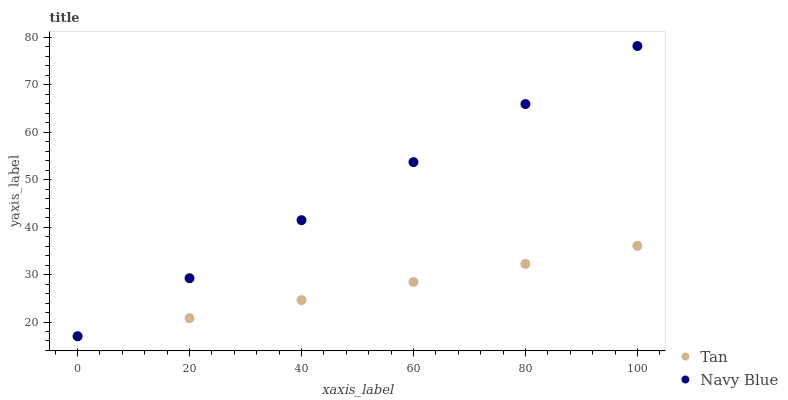Does Tan have the minimum area under the curve?
Answer yes or no. Yes. Does Navy Blue have the maximum area under the curve?
Answer yes or no. Yes. Does Tan have the maximum area under the curve?
Answer yes or no. No. Is Navy Blue the smoothest?
Answer yes or no. Yes. Is Tan the roughest?
Answer yes or no. Yes. Is Tan the smoothest?
Answer yes or no. No. Does Navy Blue have the lowest value?
Answer yes or no. Yes. Does Navy Blue have the highest value?
Answer yes or no. Yes. Does Tan have the highest value?
Answer yes or no. No. Does Navy Blue intersect Tan?
Answer yes or no. Yes. Is Navy Blue less than Tan?
Answer yes or no. No. Is Navy Blue greater than Tan?
Answer yes or no. No. 